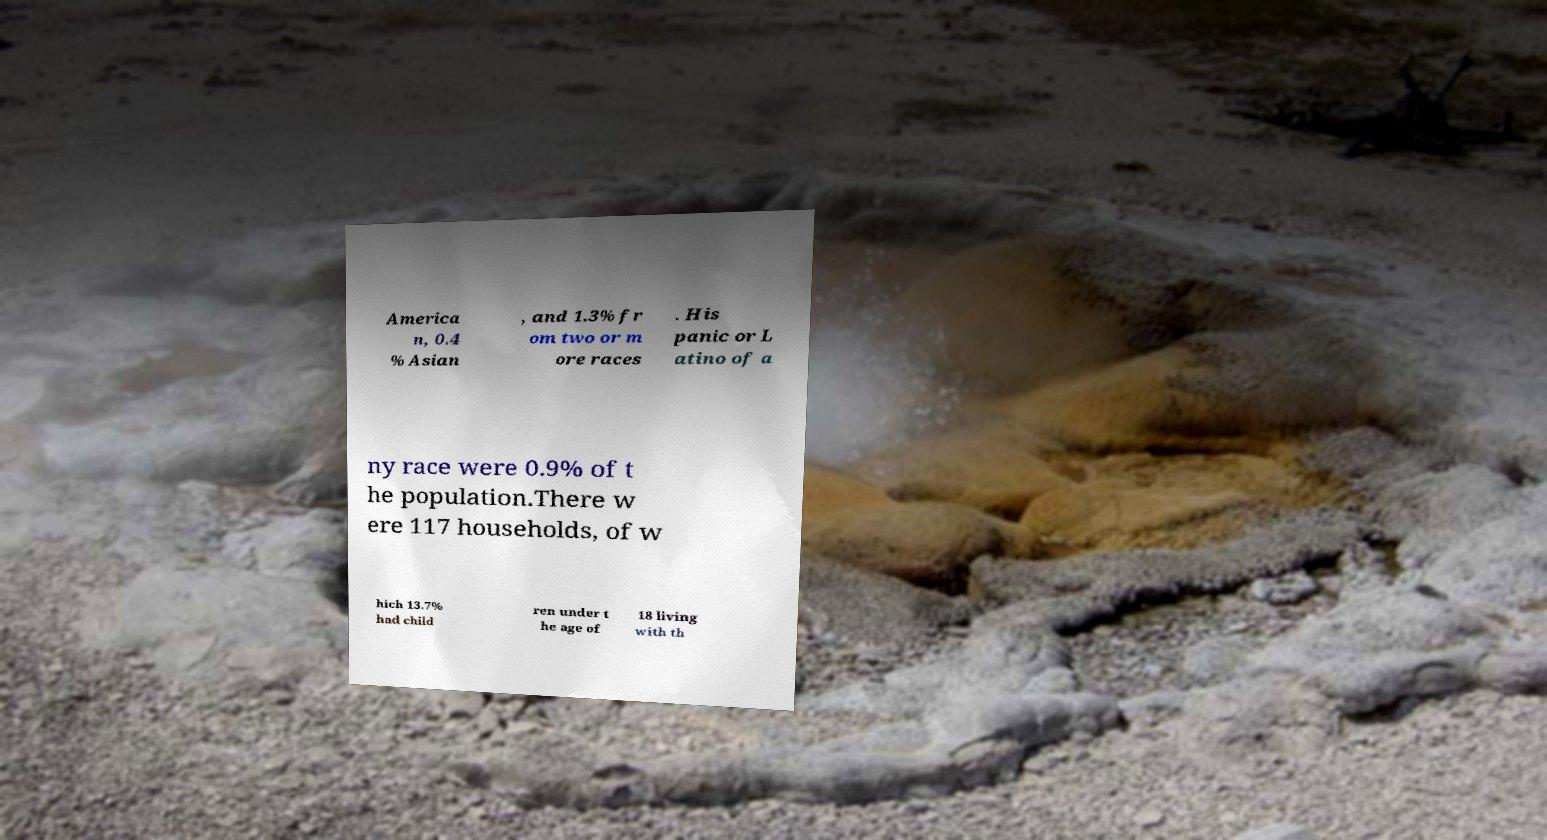Please read and relay the text visible in this image. What does it say? America n, 0.4 % Asian , and 1.3% fr om two or m ore races . His panic or L atino of a ny race were 0.9% of t he population.There w ere 117 households, of w hich 13.7% had child ren under t he age of 18 living with th 